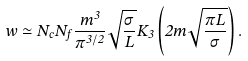Convert formula to latex. <formula><loc_0><loc_0><loc_500><loc_500>w \simeq N _ { c } N _ { f } \frac { m ^ { 3 } } { \pi ^ { 3 / 2 } } \sqrt { \frac { \sigma } { L } } K _ { 3 } \left ( 2 m \sqrt { \frac { \pi L } { \sigma } } \right ) .</formula> 